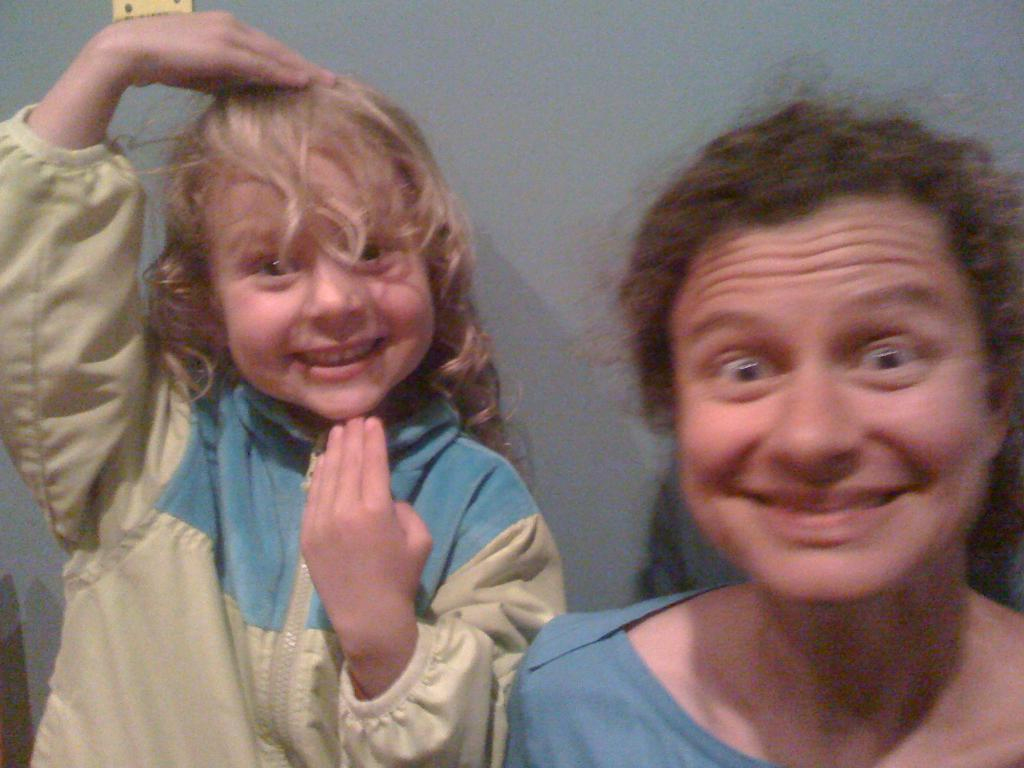Who is present in the image? There is a woman and a child in the image. What are the expressions on their faces? Both the woman and the child are smiling in the image. What color is the background of the image? The background of the image is grey. Can you see a rat in the image? No, there is no rat present in the image. What type of slip is the woman wearing in the image? There is no mention of any clothing or footwear in the image, so it is not possible to determine if the woman is wearing a slip. 